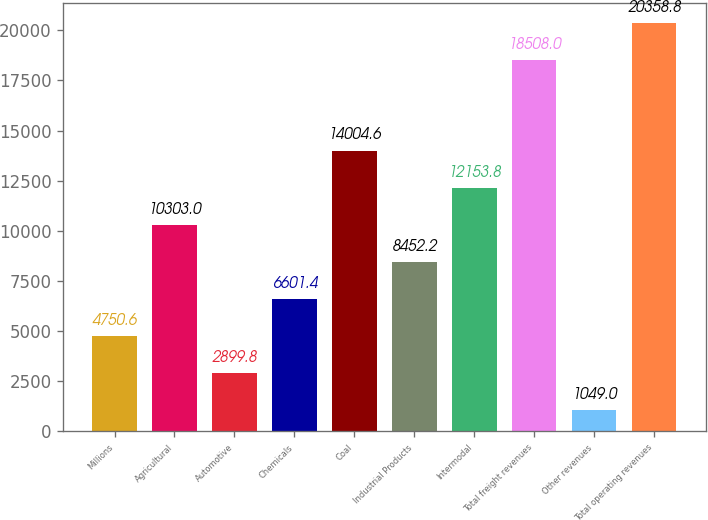Convert chart to OTSL. <chart><loc_0><loc_0><loc_500><loc_500><bar_chart><fcel>Millions<fcel>Agricultural<fcel>Automotive<fcel>Chemicals<fcel>Coal<fcel>Industrial Products<fcel>Intermodal<fcel>Total freight revenues<fcel>Other revenues<fcel>Total operating revenues<nl><fcel>4750.6<fcel>10303<fcel>2899.8<fcel>6601.4<fcel>14004.6<fcel>8452.2<fcel>12153.8<fcel>18508<fcel>1049<fcel>20358.8<nl></chart> 